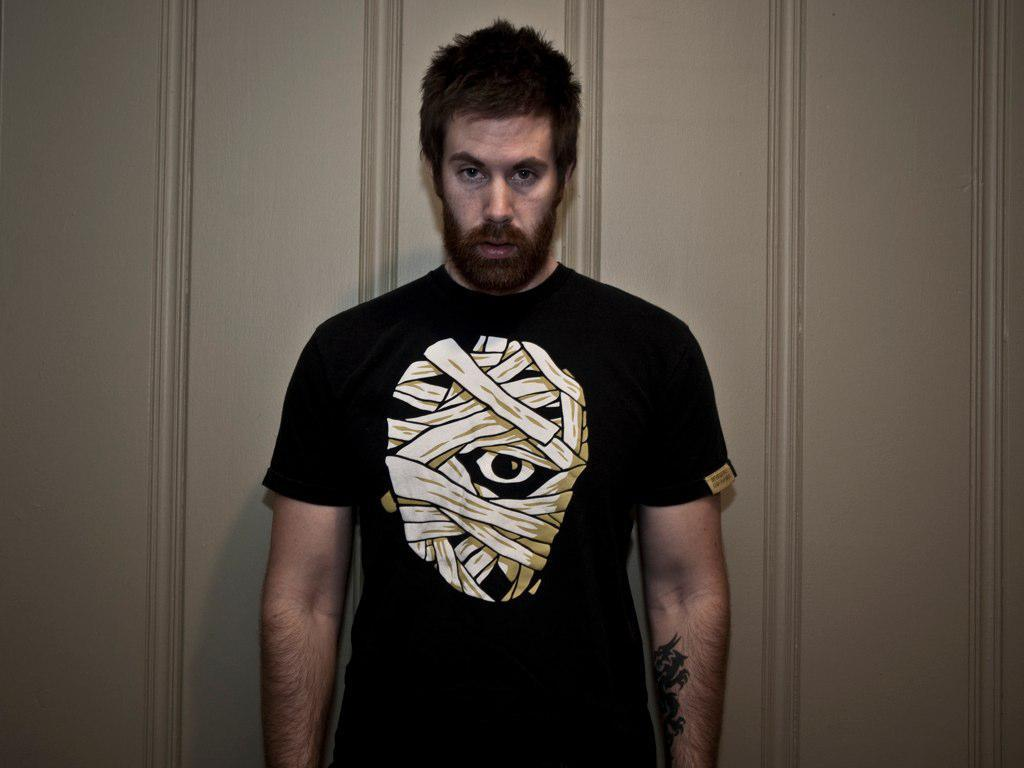What is the main subject of the image? There is a man standing in the center of the image. What is the man wearing? The man is wearing a black dress. What can be seen in the background of the image? There is a wall in the background of the image. What type of disgust can be seen on the man's face in the image? There is no indication of disgust on the man's face in the image. Can you tell me how many pails are visible in the image? There are no pails present in the image. What type of transportation is available at the airport in the image? There is no airport present in the image. 